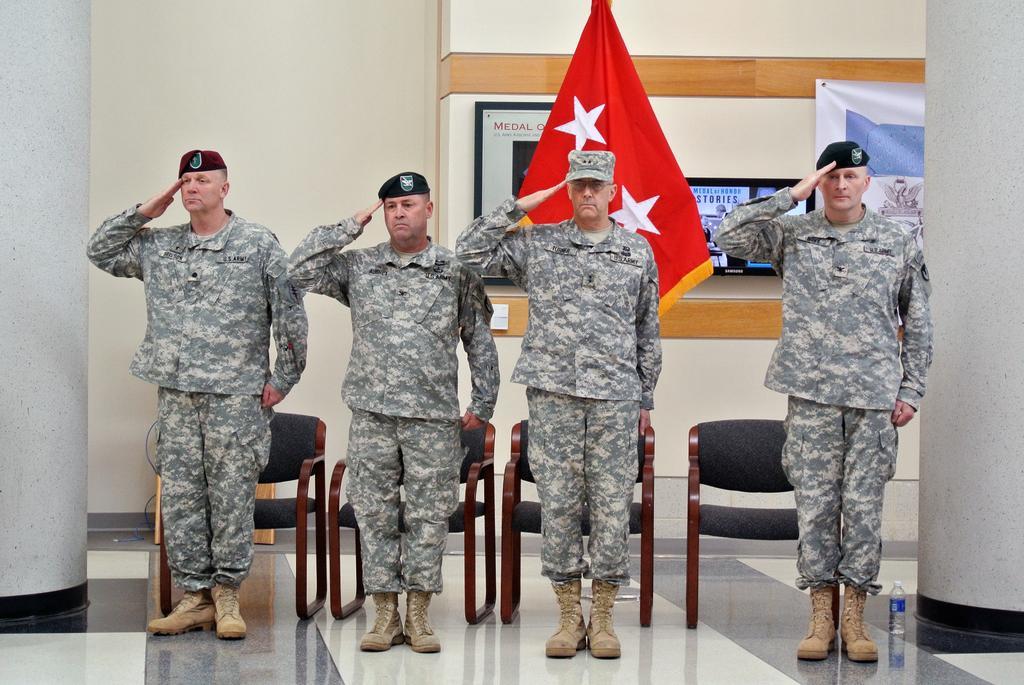In one or two sentences, can you explain what this image depicts? In this image there are persons standing in the center wearing a military dress and there are chairs, there is a flag, and in the background there are frames on the wall. On the right side there is water on the floor. 